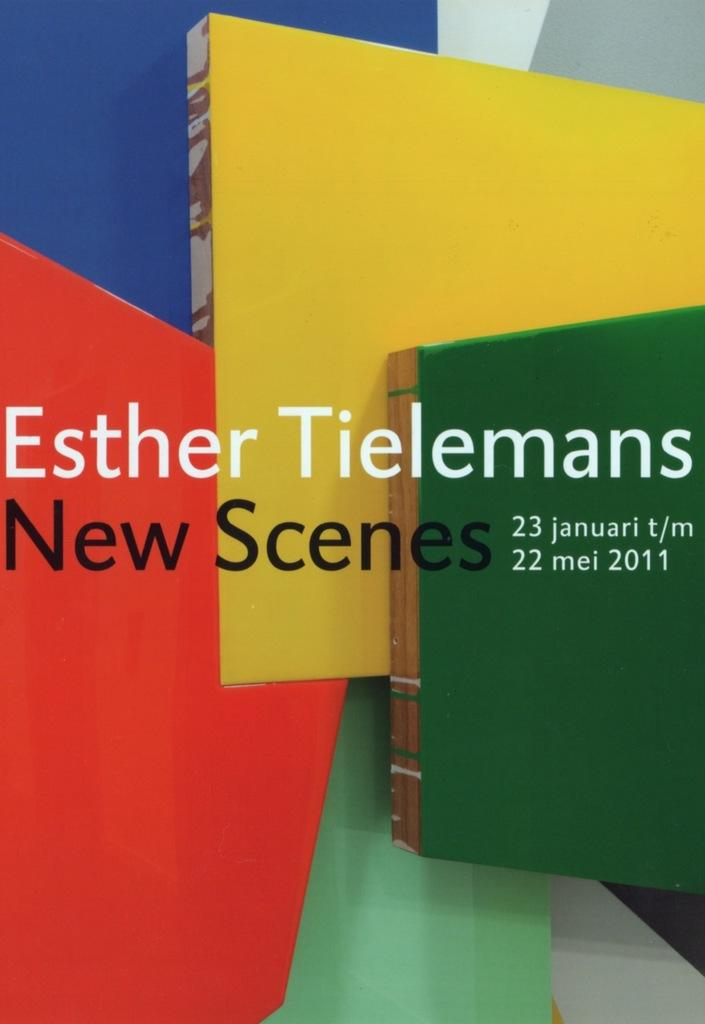Provide a one-sentence caption for the provided image. The show of Esther Tielemans opens January 23. 